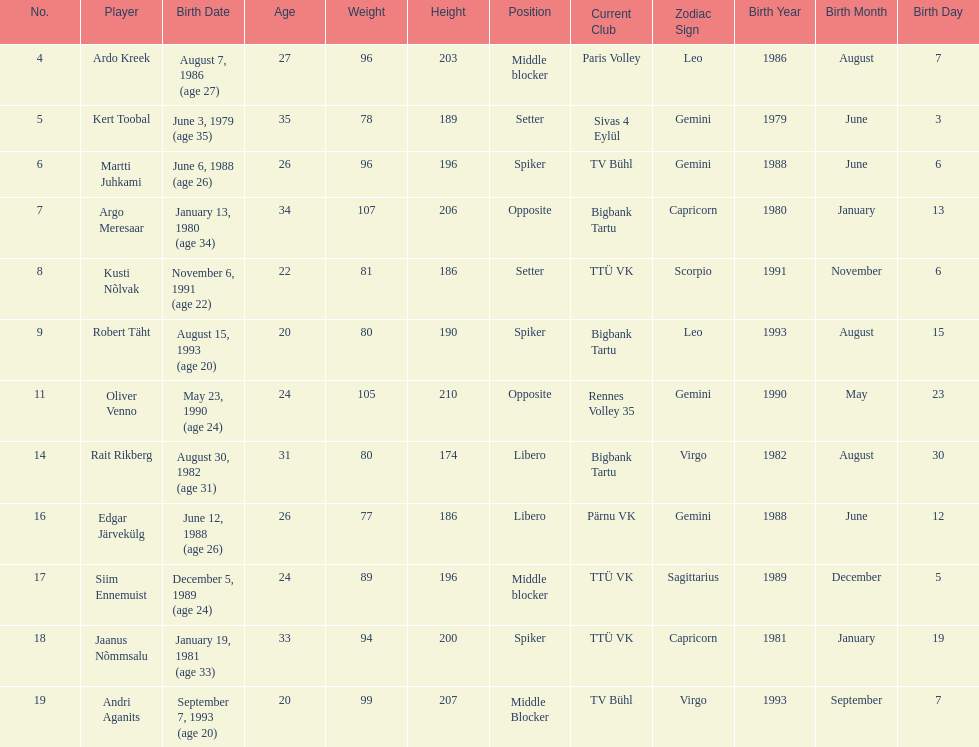Kert toobal is the oldest who is the next oldest player listed? Argo Meresaar. 